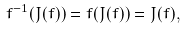<formula> <loc_0><loc_0><loc_500><loc_500>f ^ { - 1 } ( J ( f ) ) = f ( J ( f ) ) = J ( f ) ,</formula> 